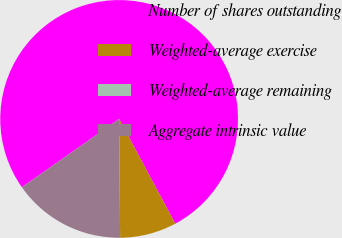Convert chart. <chart><loc_0><loc_0><loc_500><loc_500><pie_chart><fcel>Number of shares outstanding<fcel>Weighted-average exercise<fcel>Weighted-average remaining<fcel>Aggregate intrinsic value<nl><fcel>76.92%<fcel>7.69%<fcel>0.0%<fcel>15.38%<nl></chart> 